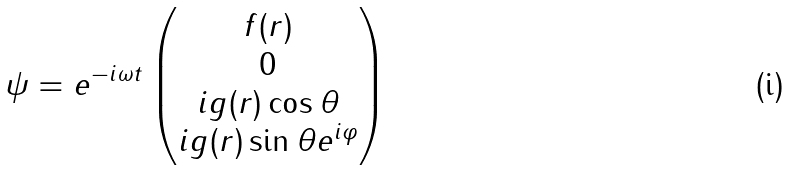Convert formula to latex. <formula><loc_0><loc_0><loc_500><loc_500>\psi = e ^ { - i \omega t } \begin{pmatrix} f ( r ) \\ 0 \\ i g ( r ) \cos \theta \\ i g ( r ) \sin \theta e ^ { i \varphi } \end{pmatrix}</formula> 